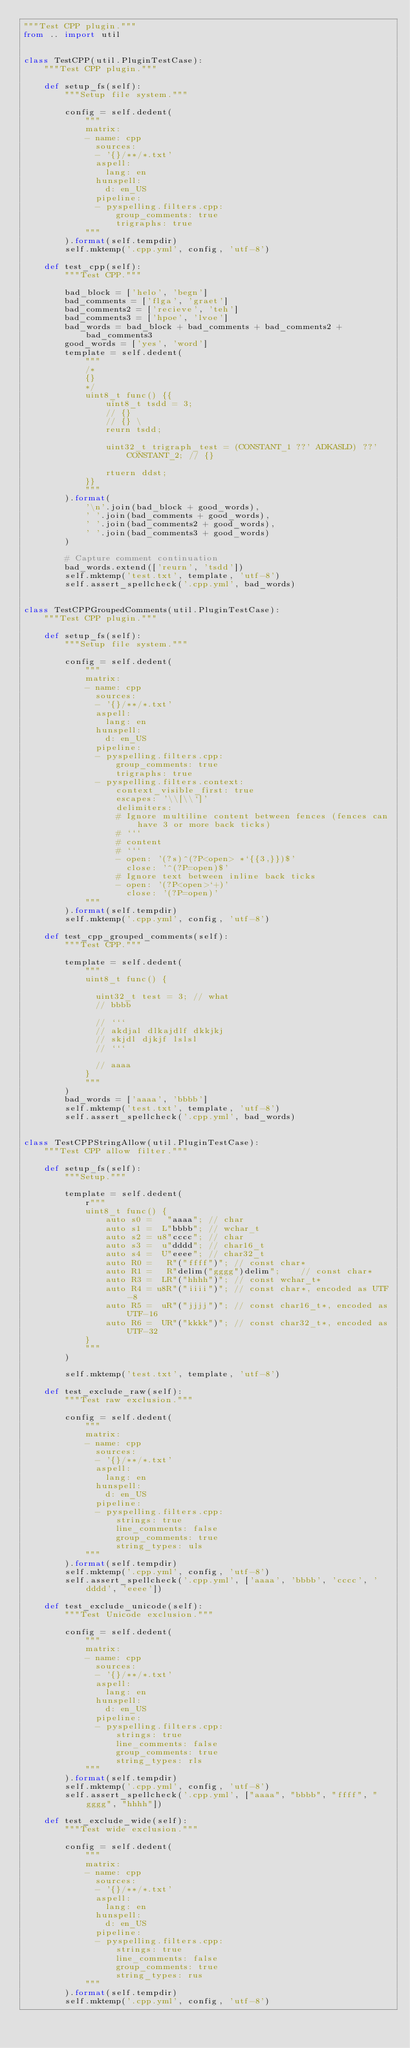Convert code to text. <code><loc_0><loc_0><loc_500><loc_500><_Python_>"""Test CPP plugin."""
from .. import util


class TestCPP(util.PluginTestCase):
    """Test CPP plugin."""

    def setup_fs(self):
        """Setup file system."""

        config = self.dedent(
            """
            matrix:
            - name: cpp
              sources:
              - '{}/**/*.txt'
              aspell:
                lang: en
              hunspell:
                d: en_US
              pipeline:
              - pyspelling.filters.cpp:
                  group_comments: true
                  trigraphs: true
            """
        ).format(self.tempdir)
        self.mktemp('.cpp.yml', config, 'utf-8')

    def test_cpp(self):
        """Test CPP."""

        bad_block = ['helo', 'begn']
        bad_comments = ['flga', 'graet']
        bad_comments2 = ['recieve', 'teh']
        bad_comments3 = ['hpoe', 'lvoe']
        bad_words = bad_block + bad_comments + bad_comments2 + bad_comments3
        good_words = ['yes', 'word']
        template = self.dedent(
            """
            /*
            {}
            */
            uint8_t func() {{
                uint8_t tsdd = 3;
                // {}
                // {} \
                reurn tsdd;

                uint32_t trigraph_test = (CONSTANT_1 ??' ADKASLD) ??' CONSTANT_2; // {}

                rtuern ddst;
            }}
            """
        ).format(
            '\n'.join(bad_block + good_words),
            ' '.join(bad_comments + good_words),
            ' '.join(bad_comments2 + good_words),
            ' '.join(bad_comments3 + good_words)
        )

        # Capture comment continuation
        bad_words.extend(['reurn', 'tsdd'])
        self.mktemp('test.txt', template, 'utf-8')
        self.assert_spellcheck('.cpp.yml', bad_words)


class TestCPPGroupedComments(util.PluginTestCase):
    """Test CPP plugin."""

    def setup_fs(self):
        """Setup file system."""

        config = self.dedent(
            """
            matrix:
            - name: cpp
              sources:
              - '{}/**/*.txt'
              aspell:
                lang: en
              hunspell:
                d: en_US
              pipeline:
              - pyspelling.filters.cpp:
                  group_comments: true
                  trigraphs: true
              - pyspelling.filters.context:
                  context_visible_first: true
                  escapes: '\\[\\`]'
                  delimiters:
                  # Ignore multiline content between fences (fences can have 3 or more back ticks)
                  # ```
                  # content
                  # ```
                  - open: '(?s)^(?P<open> *`{{3,}})$'
                    close: '^(?P=open)$'
                  # Ignore text between inline back ticks
                  - open: '(?P<open>`+)'
                    close: '(?P=open)'
            """
        ).format(self.tempdir)
        self.mktemp('.cpp.yml', config, 'utf-8')

    def test_cpp_grouped_comments(self):
        """Test CPP."""

        template = self.dedent(
            """
            uint8_t func() {

              uint32_t test = 3; // what
              // bbbb

              // ```
              // akdjal dlkajdlf dkkjkj
              // skjdl djkjf lslsl
              // ```

              // aaaa
            }
            """
        )
        bad_words = ['aaaa', 'bbbb']
        self.mktemp('test.txt', template, 'utf-8')
        self.assert_spellcheck('.cpp.yml', bad_words)


class TestCPPStringAllow(util.PluginTestCase):
    """Test CPP allow filter."""

    def setup_fs(self):
        """Setup."""

        template = self.dedent(
            r"""
            uint8_t func() {
                auto s0 =   "aaaa"; // char
                auto s1 =  L"bbbb"; // wchar_t
                auto s2 = u8"cccc"; // char
                auto s3 =  u"dddd"; // char16_t
                auto s4 =  U"eeee"; // char32_t
                auto R0 =   R"("ffff")"; // const char*
                auto R1 =   R"delim("gggg")delim";    // const char*
                auto R3 =  LR"("hhhh")"; // const wchar_t*
                auto R4 = u8R"("iiii")"; // const char*, encoded as UTF-8
                auto R5 =  uR"("jjjj")"; // const char16_t*, encoded as UTF-16
                auto R6 =  UR"("kkkk")"; // const char32_t*, encoded as UTF-32
            }
            """
        )

        self.mktemp('test.txt', template, 'utf-8')

    def test_exclude_raw(self):
        """Test raw exclusion."""

        config = self.dedent(
            """
            matrix:
            - name: cpp
              sources:
              - '{}/**/*.txt'
              aspell:
                lang: en
              hunspell:
                d: en_US
              pipeline:
              - pyspelling.filters.cpp:
                  strings: true
                  line_comments: false
                  group_comments: true
                  string_types: uls
            """
        ).format(self.tempdir)
        self.mktemp('.cpp.yml', config, 'utf-8')
        self.assert_spellcheck('.cpp.yml', ['aaaa', 'bbbb', 'cccc', 'dddd', 'eeee'])

    def test_exclude_unicode(self):
        """Test Unicode exclusion."""

        config = self.dedent(
            """
            matrix:
            - name: cpp
              sources:
              - '{}/**/*.txt'
              aspell:
                lang: en
              hunspell:
                d: en_US
              pipeline:
              - pyspelling.filters.cpp:
                  strings: true
                  line_comments: false
                  group_comments: true
                  string_types: rls
            """
        ).format(self.tempdir)
        self.mktemp('.cpp.yml', config, 'utf-8')
        self.assert_spellcheck('.cpp.yml', ["aaaa", "bbbb", "ffff", "gggg", "hhhh"])

    def test_exclude_wide(self):
        """Test wide exclusion."""

        config = self.dedent(
            """
            matrix:
            - name: cpp
              sources:
              - '{}/**/*.txt'
              aspell:
                lang: en
              hunspell:
                d: en_US
              pipeline:
              - pyspelling.filters.cpp:
                  strings: true
                  line_comments: false
                  group_comments: true
                  string_types: rus
            """
        ).format(self.tempdir)
        self.mktemp('.cpp.yml', config, 'utf-8')</code> 